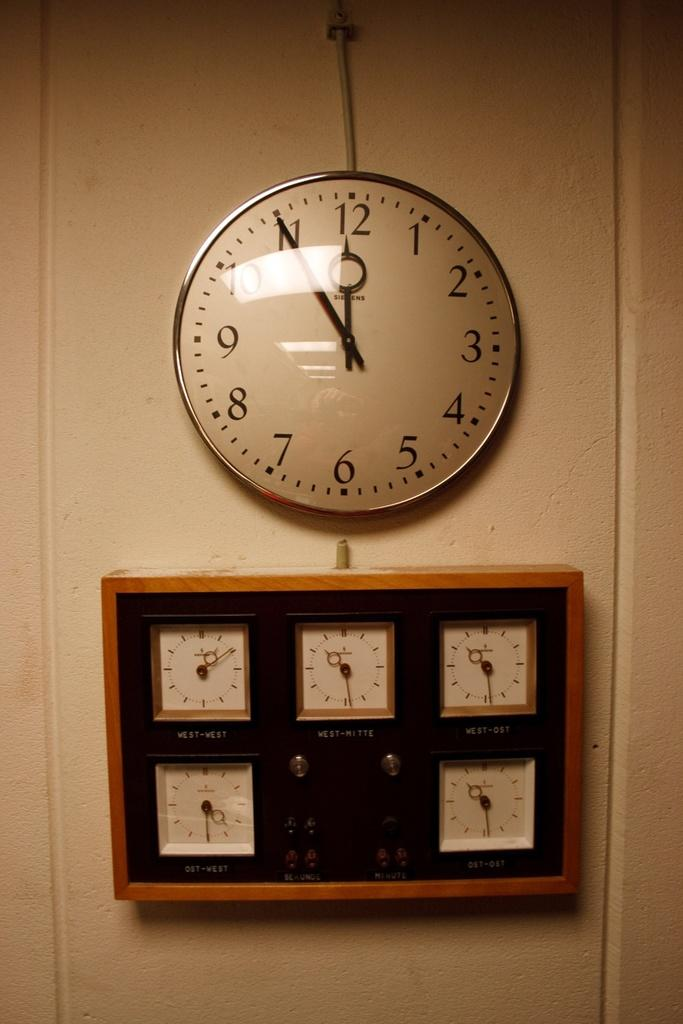Provide a one-sentence caption for the provided image. wall clock with time at 5 til 12 and rectangular wooden clock below that has 5 small clocks within it. 